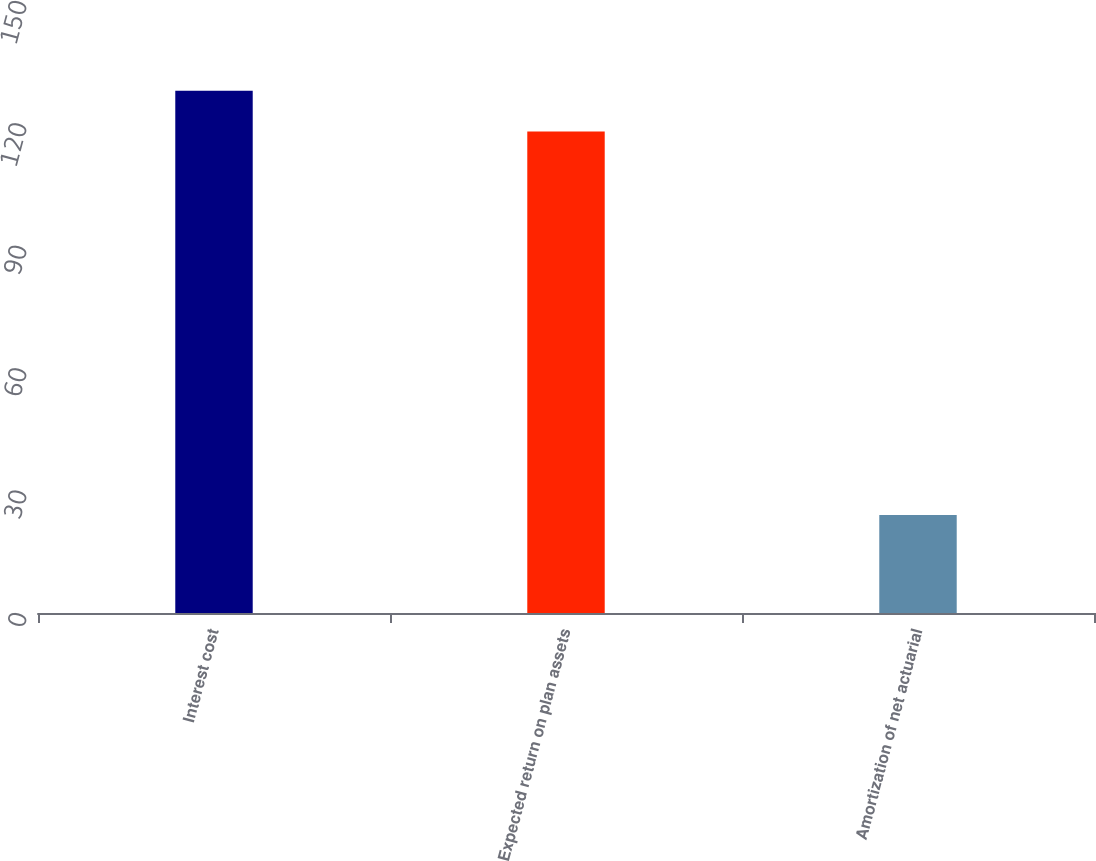Convert chart to OTSL. <chart><loc_0><loc_0><loc_500><loc_500><bar_chart><fcel>Interest cost<fcel>Expected return on plan assets<fcel>Amortization of net actuarial<nl><fcel>128<fcel>118<fcel>24<nl></chart> 